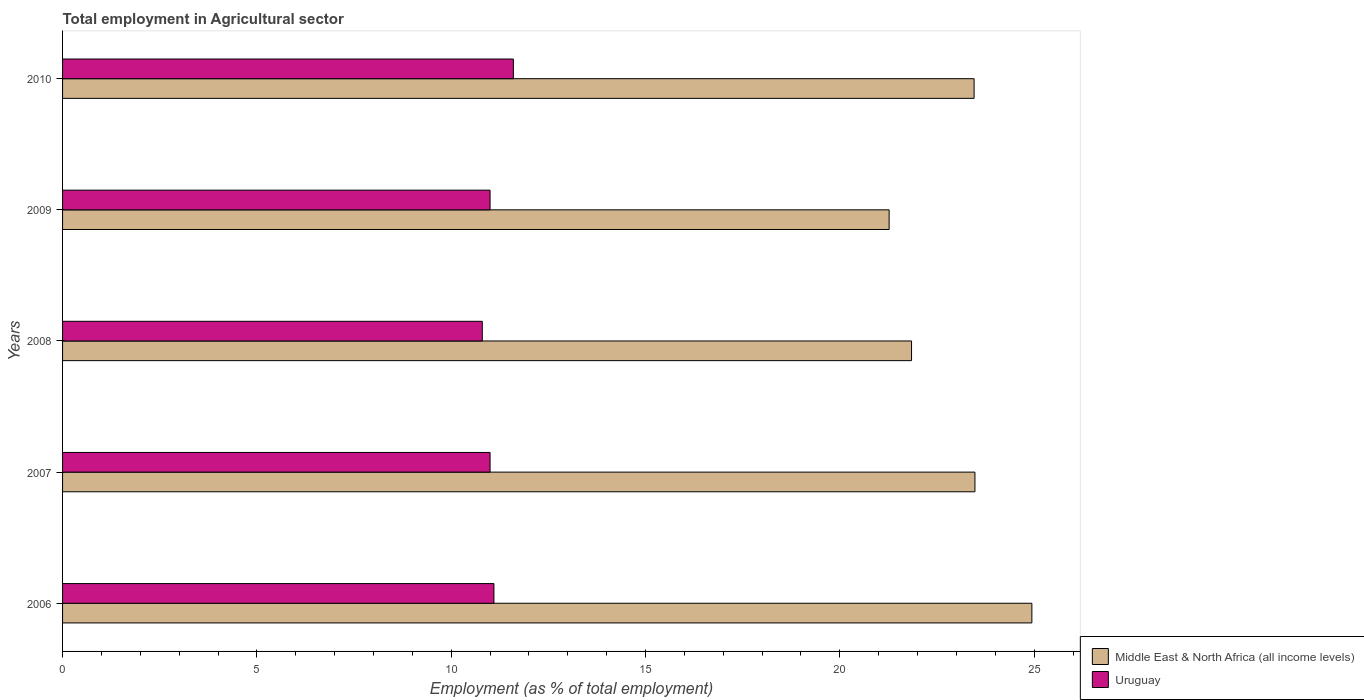How many different coloured bars are there?
Give a very brief answer. 2. How many groups of bars are there?
Offer a terse response. 5. Are the number of bars per tick equal to the number of legend labels?
Give a very brief answer. Yes. How many bars are there on the 1st tick from the top?
Give a very brief answer. 2. How many bars are there on the 2nd tick from the bottom?
Offer a terse response. 2. What is the label of the 1st group of bars from the top?
Provide a succinct answer. 2010. In how many cases, is the number of bars for a given year not equal to the number of legend labels?
Offer a terse response. 0. What is the employment in agricultural sector in Middle East & North Africa (all income levels) in 2008?
Give a very brief answer. 21.85. Across all years, what is the maximum employment in agricultural sector in Middle East & North Africa (all income levels)?
Provide a short and direct response. 24.94. Across all years, what is the minimum employment in agricultural sector in Middle East & North Africa (all income levels)?
Keep it short and to the point. 21.27. In which year was the employment in agricultural sector in Uruguay maximum?
Ensure brevity in your answer.  2010. What is the total employment in agricultural sector in Middle East & North Africa (all income levels) in the graph?
Keep it short and to the point. 114.99. What is the difference between the employment in agricultural sector in Middle East & North Africa (all income levels) in 2009 and that in 2010?
Make the answer very short. -2.19. What is the difference between the employment in agricultural sector in Uruguay in 2010 and the employment in agricultural sector in Middle East & North Africa (all income levels) in 2008?
Offer a terse response. -10.25. What is the average employment in agricultural sector in Middle East & North Africa (all income levels) per year?
Provide a short and direct response. 23. In the year 2009, what is the difference between the employment in agricultural sector in Middle East & North Africa (all income levels) and employment in agricultural sector in Uruguay?
Your response must be concise. 10.27. What is the ratio of the employment in agricultural sector in Middle East & North Africa (all income levels) in 2008 to that in 2010?
Provide a short and direct response. 0.93. Is the employment in agricultural sector in Middle East & North Africa (all income levels) in 2007 less than that in 2009?
Offer a very short reply. No. Is the difference between the employment in agricultural sector in Middle East & North Africa (all income levels) in 2006 and 2010 greater than the difference between the employment in agricultural sector in Uruguay in 2006 and 2010?
Provide a short and direct response. Yes. What is the difference between the highest and the lowest employment in agricultural sector in Middle East & North Africa (all income levels)?
Provide a succinct answer. 3.67. Is the sum of the employment in agricultural sector in Middle East & North Africa (all income levels) in 2007 and 2010 greater than the maximum employment in agricultural sector in Uruguay across all years?
Give a very brief answer. Yes. What does the 2nd bar from the top in 2007 represents?
Keep it short and to the point. Middle East & North Africa (all income levels). What does the 1st bar from the bottom in 2010 represents?
Your answer should be compact. Middle East & North Africa (all income levels). How many bars are there?
Provide a short and direct response. 10. Where does the legend appear in the graph?
Provide a short and direct response. Bottom right. How are the legend labels stacked?
Keep it short and to the point. Vertical. What is the title of the graph?
Your response must be concise. Total employment in Agricultural sector. Does "Qatar" appear as one of the legend labels in the graph?
Your answer should be compact. No. What is the label or title of the X-axis?
Your response must be concise. Employment (as % of total employment). What is the Employment (as % of total employment) of Middle East & North Africa (all income levels) in 2006?
Make the answer very short. 24.94. What is the Employment (as % of total employment) of Uruguay in 2006?
Ensure brevity in your answer.  11.1. What is the Employment (as % of total employment) in Middle East & North Africa (all income levels) in 2007?
Your answer should be very brief. 23.48. What is the Employment (as % of total employment) in Uruguay in 2007?
Provide a short and direct response. 11. What is the Employment (as % of total employment) in Middle East & North Africa (all income levels) in 2008?
Ensure brevity in your answer.  21.85. What is the Employment (as % of total employment) in Uruguay in 2008?
Provide a succinct answer. 10.8. What is the Employment (as % of total employment) of Middle East & North Africa (all income levels) in 2009?
Ensure brevity in your answer.  21.27. What is the Employment (as % of total employment) in Uruguay in 2009?
Ensure brevity in your answer.  11. What is the Employment (as % of total employment) of Middle East & North Africa (all income levels) in 2010?
Keep it short and to the point. 23.45. What is the Employment (as % of total employment) of Uruguay in 2010?
Make the answer very short. 11.6. Across all years, what is the maximum Employment (as % of total employment) of Middle East & North Africa (all income levels)?
Offer a very short reply. 24.94. Across all years, what is the maximum Employment (as % of total employment) of Uruguay?
Ensure brevity in your answer.  11.6. Across all years, what is the minimum Employment (as % of total employment) of Middle East & North Africa (all income levels)?
Your response must be concise. 21.27. Across all years, what is the minimum Employment (as % of total employment) in Uruguay?
Keep it short and to the point. 10.8. What is the total Employment (as % of total employment) in Middle East & North Africa (all income levels) in the graph?
Ensure brevity in your answer.  114.99. What is the total Employment (as % of total employment) in Uruguay in the graph?
Your answer should be compact. 55.5. What is the difference between the Employment (as % of total employment) in Middle East & North Africa (all income levels) in 2006 and that in 2007?
Provide a succinct answer. 1.47. What is the difference between the Employment (as % of total employment) in Uruguay in 2006 and that in 2007?
Provide a succinct answer. 0.1. What is the difference between the Employment (as % of total employment) in Middle East & North Africa (all income levels) in 2006 and that in 2008?
Make the answer very short. 3.1. What is the difference between the Employment (as % of total employment) of Middle East & North Africa (all income levels) in 2006 and that in 2009?
Your answer should be compact. 3.67. What is the difference between the Employment (as % of total employment) of Uruguay in 2006 and that in 2009?
Make the answer very short. 0.1. What is the difference between the Employment (as % of total employment) in Middle East & North Africa (all income levels) in 2006 and that in 2010?
Offer a terse response. 1.49. What is the difference between the Employment (as % of total employment) of Middle East & North Africa (all income levels) in 2007 and that in 2008?
Offer a very short reply. 1.63. What is the difference between the Employment (as % of total employment) in Middle East & North Africa (all income levels) in 2007 and that in 2009?
Provide a succinct answer. 2.21. What is the difference between the Employment (as % of total employment) in Uruguay in 2007 and that in 2009?
Your answer should be compact. 0. What is the difference between the Employment (as % of total employment) in Middle East & North Africa (all income levels) in 2007 and that in 2010?
Keep it short and to the point. 0.02. What is the difference between the Employment (as % of total employment) of Middle East & North Africa (all income levels) in 2008 and that in 2009?
Your response must be concise. 0.58. What is the difference between the Employment (as % of total employment) of Uruguay in 2008 and that in 2009?
Your answer should be compact. -0.2. What is the difference between the Employment (as % of total employment) of Middle East & North Africa (all income levels) in 2008 and that in 2010?
Keep it short and to the point. -1.61. What is the difference between the Employment (as % of total employment) in Middle East & North Africa (all income levels) in 2009 and that in 2010?
Your answer should be very brief. -2.19. What is the difference between the Employment (as % of total employment) in Uruguay in 2009 and that in 2010?
Make the answer very short. -0.6. What is the difference between the Employment (as % of total employment) in Middle East & North Africa (all income levels) in 2006 and the Employment (as % of total employment) in Uruguay in 2007?
Ensure brevity in your answer.  13.94. What is the difference between the Employment (as % of total employment) of Middle East & North Africa (all income levels) in 2006 and the Employment (as % of total employment) of Uruguay in 2008?
Make the answer very short. 14.14. What is the difference between the Employment (as % of total employment) in Middle East & North Africa (all income levels) in 2006 and the Employment (as % of total employment) in Uruguay in 2009?
Offer a terse response. 13.94. What is the difference between the Employment (as % of total employment) of Middle East & North Africa (all income levels) in 2006 and the Employment (as % of total employment) of Uruguay in 2010?
Your response must be concise. 13.34. What is the difference between the Employment (as % of total employment) of Middle East & North Africa (all income levels) in 2007 and the Employment (as % of total employment) of Uruguay in 2008?
Keep it short and to the point. 12.68. What is the difference between the Employment (as % of total employment) of Middle East & North Africa (all income levels) in 2007 and the Employment (as % of total employment) of Uruguay in 2009?
Offer a terse response. 12.48. What is the difference between the Employment (as % of total employment) of Middle East & North Africa (all income levels) in 2007 and the Employment (as % of total employment) of Uruguay in 2010?
Ensure brevity in your answer.  11.88. What is the difference between the Employment (as % of total employment) of Middle East & North Africa (all income levels) in 2008 and the Employment (as % of total employment) of Uruguay in 2009?
Make the answer very short. 10.85. What is the difference between the Employment (as % of total employment) of Middle East & North Africa (all income levels) in 2008 and the Employment (as % of total employment) of Uruguay in 2010?
Make the answer very short. 10.25. What is the difference between the Employment (as % of total employment) of Middle East & North Africa (all income levels) in 2009 and the Employment (as % of total employment) of Uruguay in 2010?
Your answer should be compact. 9.67. What is the average Employment (as % of total employment) in Middle East & North Africa (all income levels) per year?
Give a very brief answer. 23. What is the average Employment (as % of total employment) in Uruguay per year?
Provide a short and direct response. 11.1. In the year 2006, what is the difference between the Employment (as % of total employment) in Middle East & North Africa (all income levels) and Employment (as % of total employment) in Uruguay?
Your response must be concise. 13.84. In the year 2007, what is the difference between the Employment (as % of total employment) of Middle East & North Africa (all income levels) and Employment (as % of total employment) of Uruguay?
Make the answer very short. 12.48. In the year 2008, what is the difference between the Employment (as % of total employment) of Middle East & North Africa (all income levels) and Employment (as % of total employment) of Uruguay?
Provide a short and direct response. 11.05. In the year 2009, what is the difference between the Employment (as % of total employment) of Middle East & North Africa (all income levels) and Employment (as % of total employment) of Uruguay?
Your answer should be compact. 10.27. In the year 2010, what is the difference between the Employment (as % of total employment) of Middle East & North Africa (all income levels) and Employment (as % of total employment) of Uruguay?
Make the answer very short. 11.85. What is the ratio of the Employment (as % of total employment) of Middle East & North Africa (all income levels) in 2006 to that in 2007?
Make the answer very short. 1.06. What is the ratio of the Employment (as % of total employment) of Uruguay in 2006 to that in 2007?
Offer a very short reply. 1.01. What is the ratio of the Employment (as % of total employment) of Middle East & North Africa (all income levels) in 2006 to that in 2008?
Your answer should be compact. 1.14. What is the ratio of the Employment (as % of total employment) of Uruguay in 2006 to that in 2008?
Ensure brevity in your answer.  1.03. What is the ratio of the Employment (as % of total employment) in Middle East & North Africa (all income levels) in 2006 to that in 2009?
Ensure brevity in your answer.  1.17. What is the ratio of the Employment (as % of total employment) of Uruguay in 2006 to that in 2009?
Ensure brevity in your answer.  1.01. What is the ratio of the Employment (as % of total employment) of Middle East & North Africa (all income levels) in 2006 to that in 2010?
Ensure brevity in your answer.  1.06. What is the ratio of the Employment (as % of total employment) in Uruguay in 2006 to that in 2010?
Ensure brevity in your answer.  0.96. What is the ratio of the Employment (as % of total employment) in Middle East & North Africa (all income levels) in 2007 to that in 2008?
Offer a very short reply. 1.07. What is the ratio of the Employment (as % of total employment) in Uruguay in 2007 to that in 2008?
Your answer should be compact. 1.02. What is the ratio of the Employment (as % of total employment) in Middle East & North Africa (all income levels) in 2007 to that in 2009?
Your answer should be compact. 1.1. What is the ratio of the Employment (as % of total employment) in Middle East & North Africa (all income levels) in 2007 to that in 2010?
Make the answer very short. 1. What is the ratio of the Employment (as % of total employment) of Uruguay in 2007 to that in 2010?
Your answer should be compact. 0.95. What is the ratio of the Employment (as % of total employment) in Middle East & North Africa (all income levels) in 2008 to that in 2009?
Provide a succinct answer. 1.03. What is the ratio of the Employment (as % of total employment) in Uruguay in 2008 to that in 2009?
Provide a short and direct response. 0.98. What is the ratio of the Employment (as % of total employment) in Middle East & North Africa (all income levels) in 2008 to that in 2010?
Provide a succinct answer. 0.93. What is the ratio of the Employment (as % of total employment) in Middle East & North Africa (all income levels) in 2009 to that in 2010?
Give a very brief answer. 0.91. What is the ratio of the Employment (as % of total employment) of Uruguay in 2009 to that in 2010?
Provide a succinct answer. 0.95. What is the difference between the highest and the second highest Employment (as % of total employment) of Middle East & North Africa (all income levels)?
Your answer should be very brief. 1.47. What is the difference between the highest and the second highest Employment (as % of total employment) of Uruguay?
Your answer should be compact. 0.5. What is the difference between the highest and the lowest Employment (as % of total employment) of Middle East & North Africa (all income levels)?
Make the answer very short. 3.67. What is the difference between the highest and the lowest Employment (as % of total employment) of Uruguay?
Provide a short and direct response. 0.8. 